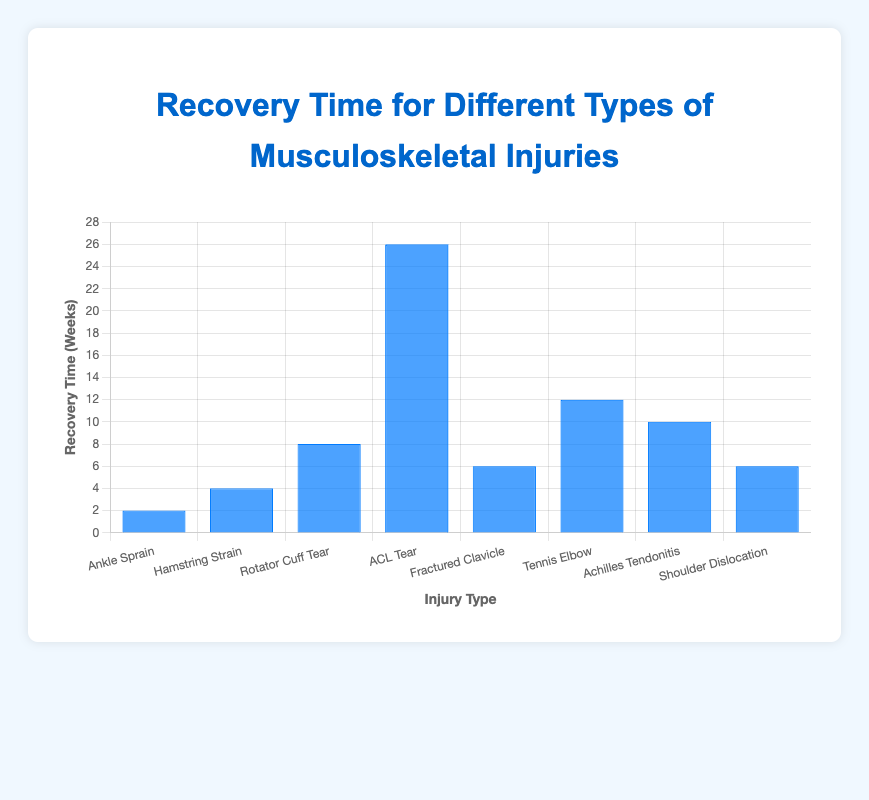Which injury type has the longest recovery time? By looking at the heights of the bars, the "ACL Tear" has the tallest bar, indicating the longest recovery time.
Answer: ACL Tear Which injury type has the shortest recovery time? The shortest bar represents "Ankle Sprain," indicating it has the shortest recovery time.
Answer: Ankle Sprain How much longer is the recovery time for a Rotator Cuff Tear than for an Ankle Sprain? The recovery time for a "Rotator Cuff Tear" is 8 weeks and for an "Ankle Sprain" is 2 weeks. Subtracting these gives 8 - 2 = 6 weeks.
Answer: 6 weeks Which injury requires more recovery time: Hamstring Strain or Tennis Elbow? By comparing the heights of the bars, "Tennis Elbow" has a taller bar than "Hamstring Strain," indicating it requires more recovery time.
Answer: Tennis Elbow What is the average recovery time for Hamstring Strain, Fractured Clavicle, and Shoulder Dislocation? The recovery times are 4 weeks (Hamstring Strain), 6 weeks (Fractured Clavicle), and 6 weeks (Shoulder Dislocation). The average is (4 + 6 + 6) / 3 = 16 / 3 ≈ 5.33 weeks.
Answer: 5.33 weeks Which injury types have the same recovery time? By visually comparing the bar heights, both "Fractured Clavicle" and "Shoulder Dislocation" have the same height, indicating the same recovery time of 6 weeks.
Answer: Fractured Clavicle, Shoulder Dislocation How does the recovery time for Achilles Tendonitis compare to that for Rotator Cuff Tear? The "Achilles Tendonitis" bar is slightly shorter than the "Rotator Cuff Tear" bar, indicating a shorter recovery time. Achilles Tendonitis takes 10 weeks versus 8 weeks for Rotator Cuff Tear.
Answer: Shorter What is the total recovery time for Ankle Sprain, Hamstring Strain, and ACL Tear? The recovery times are 2 weeks (Ankle Sprain), 4 weeks (Hamstring Strain), and 26 weeks (ACL Tear). Summing these gives 2 + 4 + 26 = 32 weeks.
Answer: 32 weeks Which injury requires a longer recovery time: Fractured Clavicle or Achilles Tendonitis? By comparing the heights of the bars, "Achilles Tendonitis" (10 weeks) has a taller bar than "Fractured Clavicle" (6 weeks), indicating a longer recovery time.
Answer: Achilles Tendonitis 